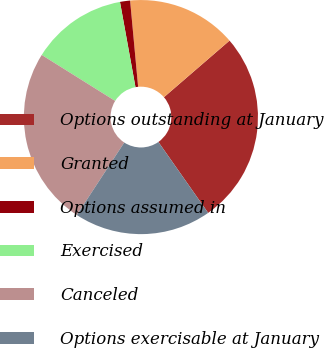<chart> <loc_0><loc_0><loc_500><loc_500><pie_chart><fcel>Options outstanding at January<fcel>Granted<fcel>Options assumed in<fcel>Exercised<fcel>Canceled<fcel>Options exercisable at January<nl><fcel>26.59%<fcel>15.14%<fcel>1.39%<fcel>13.23%<fcel>24.68%<fcel>18.96%<nl></chart> 